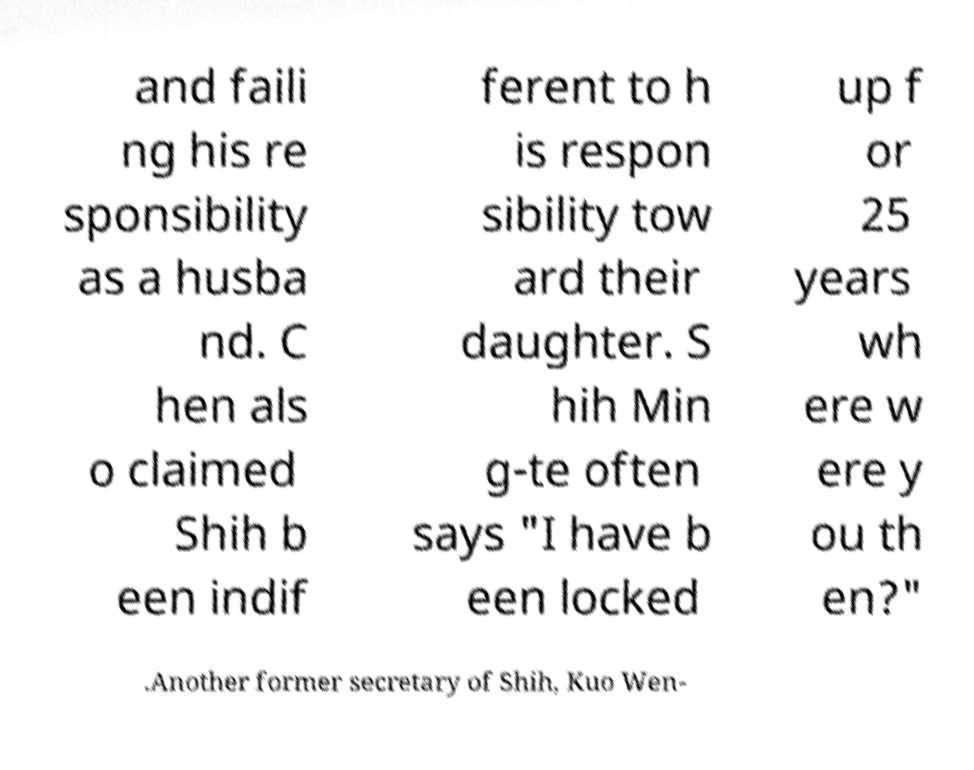There's text embedded in this image that I need extracted. Can you transcribe it verbatim? and faili ng his re sponsibility as a husba nd. C hen als o claimed Shih b een indif ferent to h is respon sibility tow ard their daughter. S hih Min g-te often says "I have b een locked up f or 25 years wh ere w ere y ou th en?" .Another former secretary of Shih, Kuo Wen- 